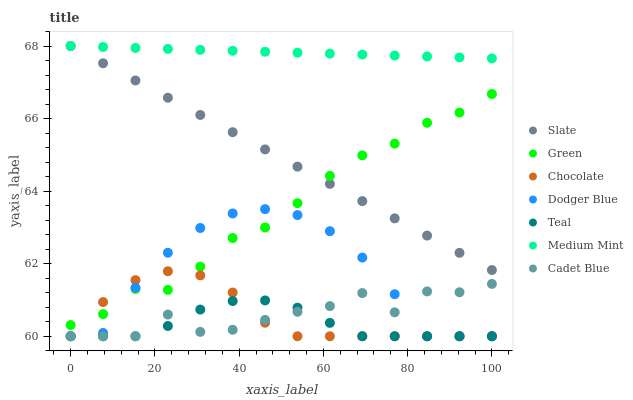Does Teal have the minimum area under the curve?
Answer yes or no. Yes. Does Medium Mint have the maximum area under the curve?
Answer yes or no. Yes. Does Cadet Blue have the minimum area under the curve?
Answer yes or no. No. Does Cadet Blue have the maximum area under the curve?
Answer yes or no. No. Is Medium Mint the smoothest?
Answer yes or no. Yes. Is Cadet Blue the roughest?
Answer yes or no. Yes. Is Slate the smoothest?
Answer yes or no. No. Is Slate the roughest?
Answer yes or no. No. Does Cadet Blue have the lowest value?
Answer yes or no. Yes. Does Slate have the lowest value?
Answer yes or no. No. Does Slate have the highest value?
Answer yes or no. Yes. Does Cadet Blue have the highest value?
Answer yes or no. No. Is Chocolate less than Slate?
Answer yes or no. Yes. Is Green greater than Teal?
Answer yes or no. Yes. Does Teal intersect Chocolate?
Answer yes or no. Yes. Is Teal less than Chocolate?
Answer yes or no. No. Is Teal greater than Chocolate?
Answer yes or no. No. Does Chocolate intersect Slate?
Answer yes or no. No. 